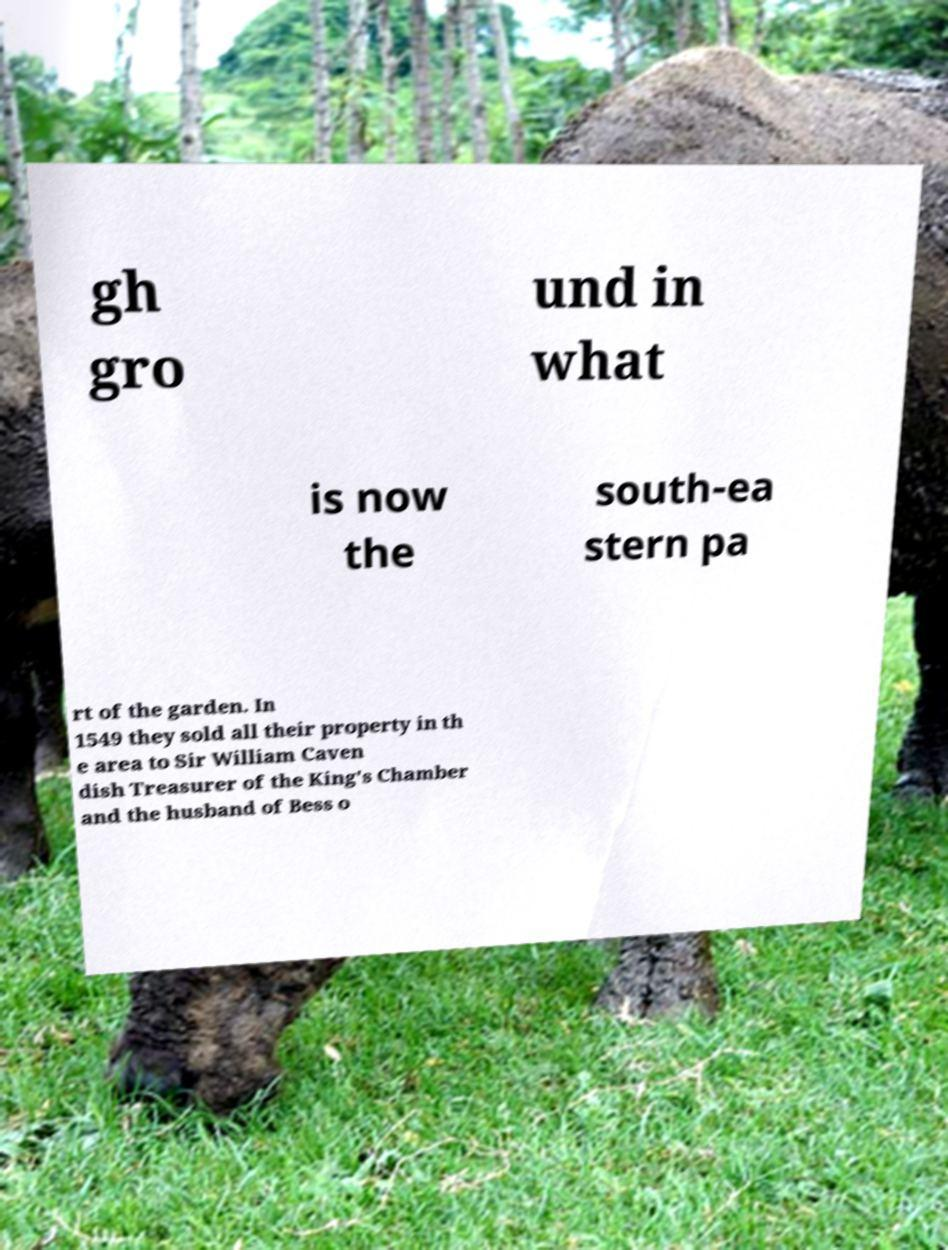Please identify and transcribe the text found in this image. gh gro und in what is now the south-ea stern pa rt of the garden. In 1549 they sold all their property in th e area to Sir William Caven dish Treasurer of the King's Chamber and the husband of Bess o 